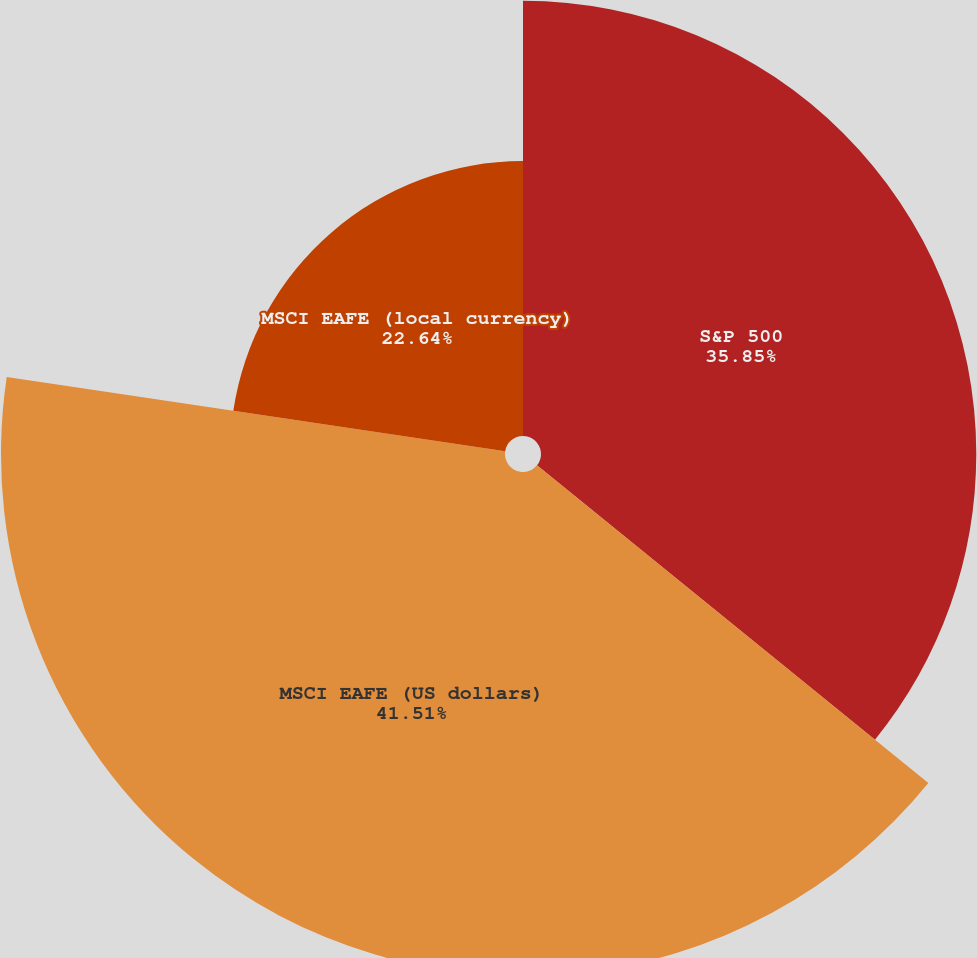Convert chart to OTSL. <chart><loc_0><loc_0><loc_500><loc_500><pie_chart><fcel>S&P 500<fcel>MSCI EAFE (US dollars)<fcel>MSCI EAFE (local currency)<nl><fcel>35.85%<fcel>41.51%<fcel>22.64%<nl></chart> 